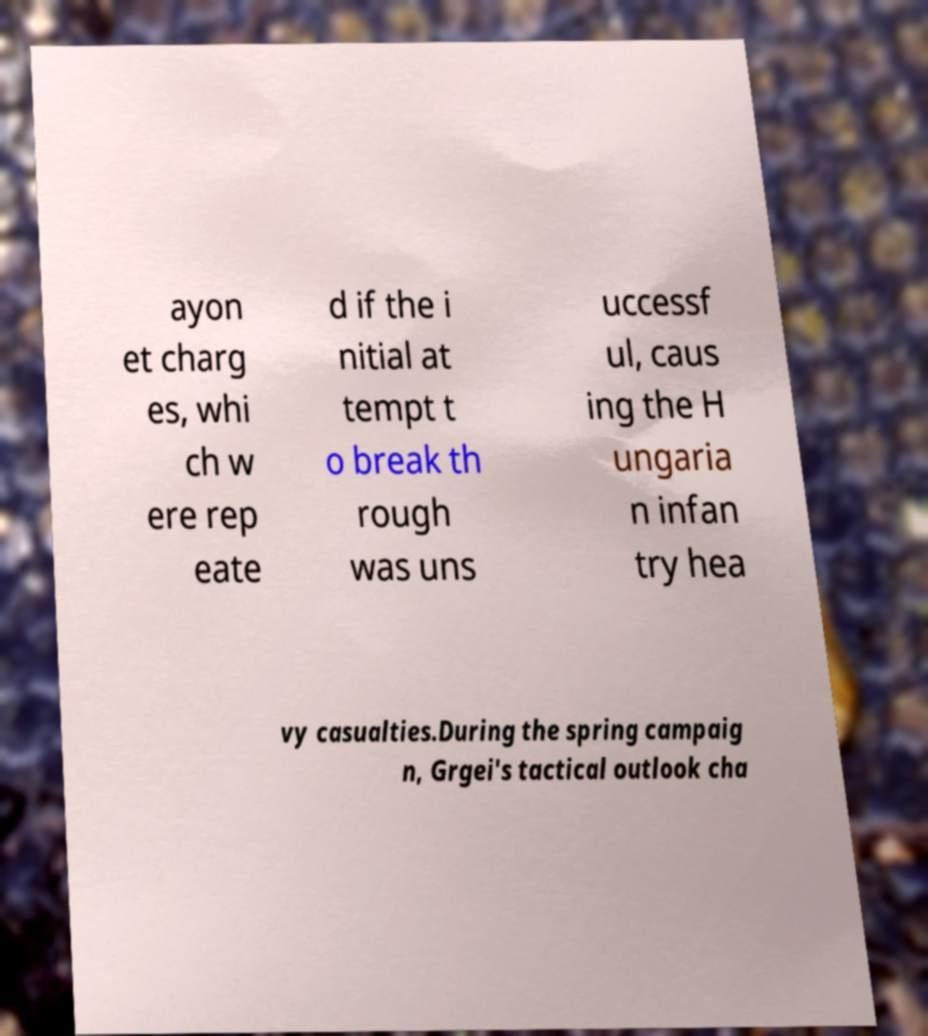Can you accurately transcribe the text from the provided image for me? ayon et charg es, whi ch w ere rep eate d if the i nitial at tempt t o break th rough was uns uccessf ul, caus ing the H ungaria n infan try hea vy casualties.During the spring campaig n, Grgei's tactical outlook cha 